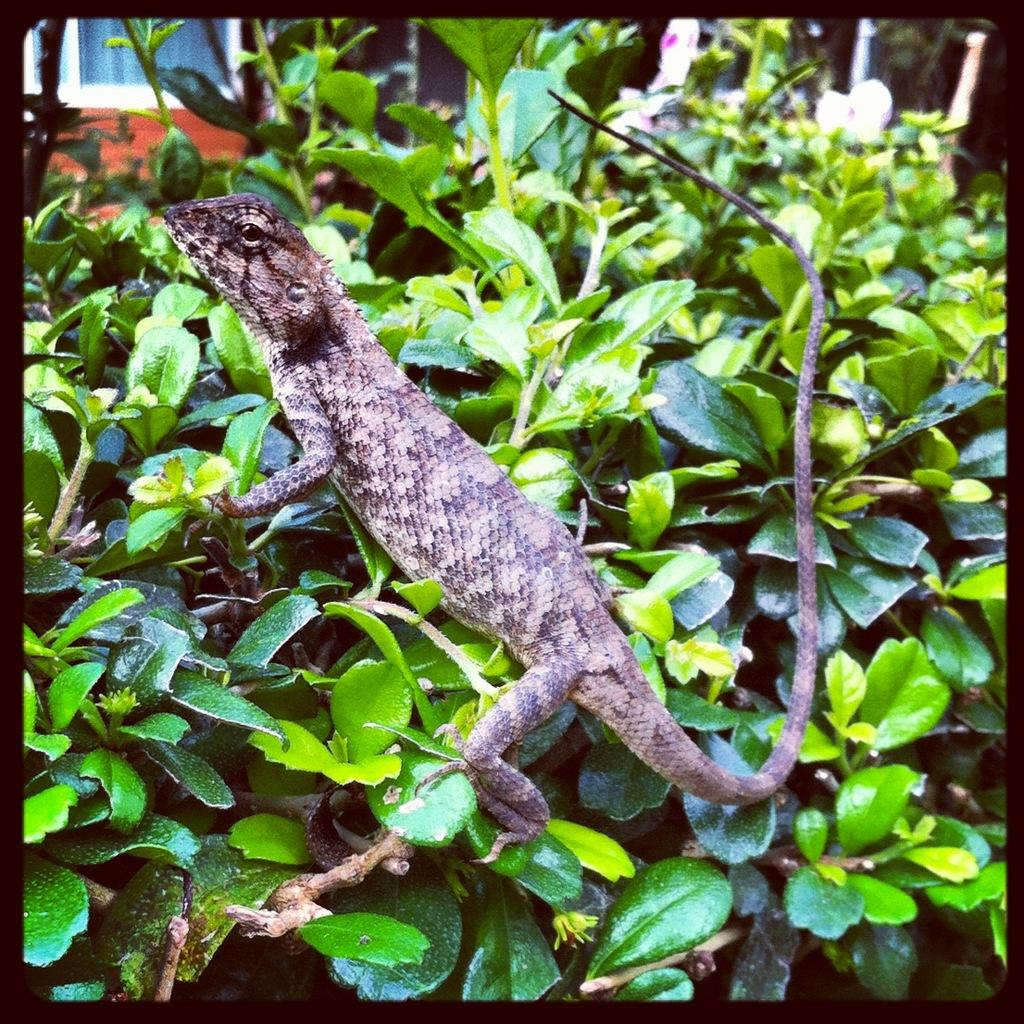What type of animal is in the image? There is a reptile in the image. Can you describe the color of the reptile? The reptile is brown and black in color. Where is the reptile located in the image? The reptile is on a plant. What can be seen in the background of the image? There is a house visible in the background of the image. How many boots are visible in the image? There are no boots present in the image. What type of hydrant can be seen near the house in the image? There is no hydrant visible in the image; only a house is mentioned in the background. 